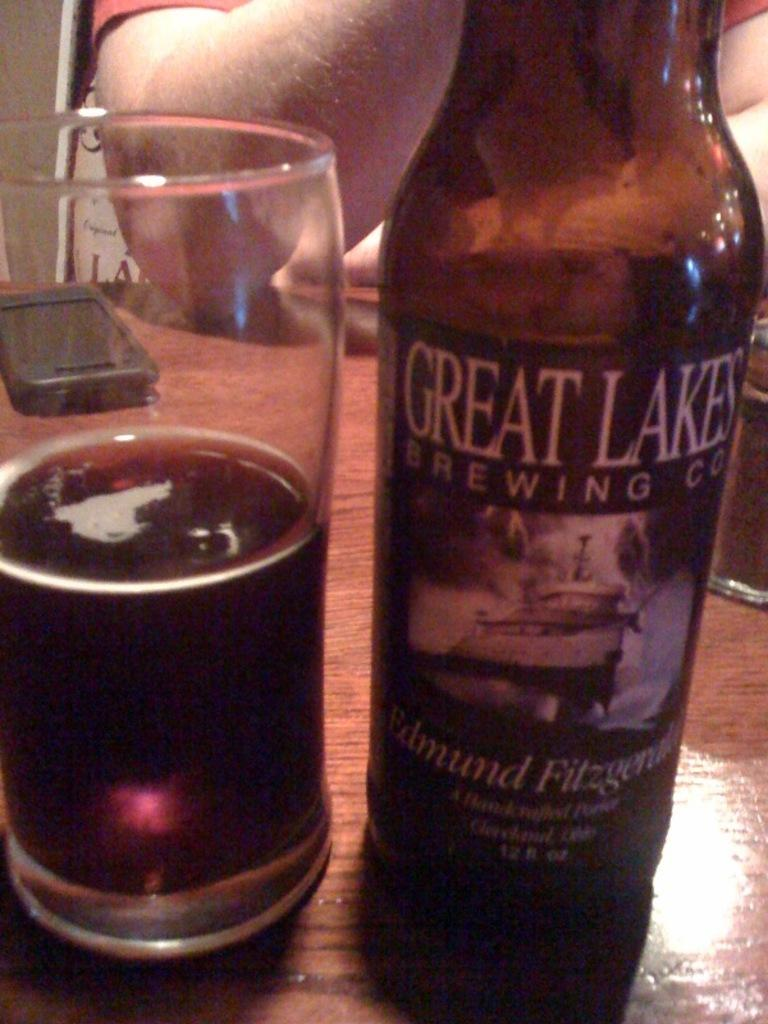Who or what is present in the image? There is a person in the image. What is the person doing with their hand? The person's hand is on the table. What is on the table along with the person's hand? There is a glass with a drink and a bottle on the table. What is written on the glass and the bottle? Both the glass and the bottle have a label that says 'GREAT LAKES'. What else can be seen on the table? There is a mobile on the table. What type of bead is being used by the writer in the image? There is no bead or writer present in the image. What brand of toothpaste is being used by the person in the image? There is no toothpaste mentioned or visible in the image. 